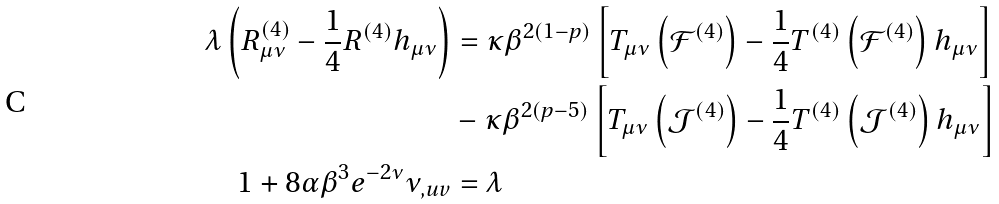Convert formula to latex. <formula><loc_0><loc_0><loc_500><loc_500>\lambda \left ( R ^ { ( 4 ) } _ { \mu \nu } - \frac { 1 } { 4 } R ^ { ( 4 ) } h _ { \mu \nu } \right ) & = \kappa \beta ^ { 2 ( 1 - p ) } \left [ T _ { \mu \nu } \left ( \mathcal { F } ^ { ( 4 ) } \right ) - \frac { 1 } { 4 } T ^ { ( 4 ) } \left ( \mathcal { F } ^ { ( 4 ) } \right ) h _ { \mu \nu } \right ] \\ & - \kappa \beta ^ { 2 ( p - 5 ) } \left [ T _ { \mu \nu } \left ( \mathcal { J } ^ { ( 4 ) } \right ) - \frac { 1 } { 4 } T ^ { ( 4 ) } \left ( \mathcal { J } ^ { ( 4 ) } \right ) h _ { \mu \nu } \right ] \\ 1 + 8 \alpha \beta ^ { 3 } e ^ { - 2 \nu } \nu _ { , u v } & = \lambda</formula> 